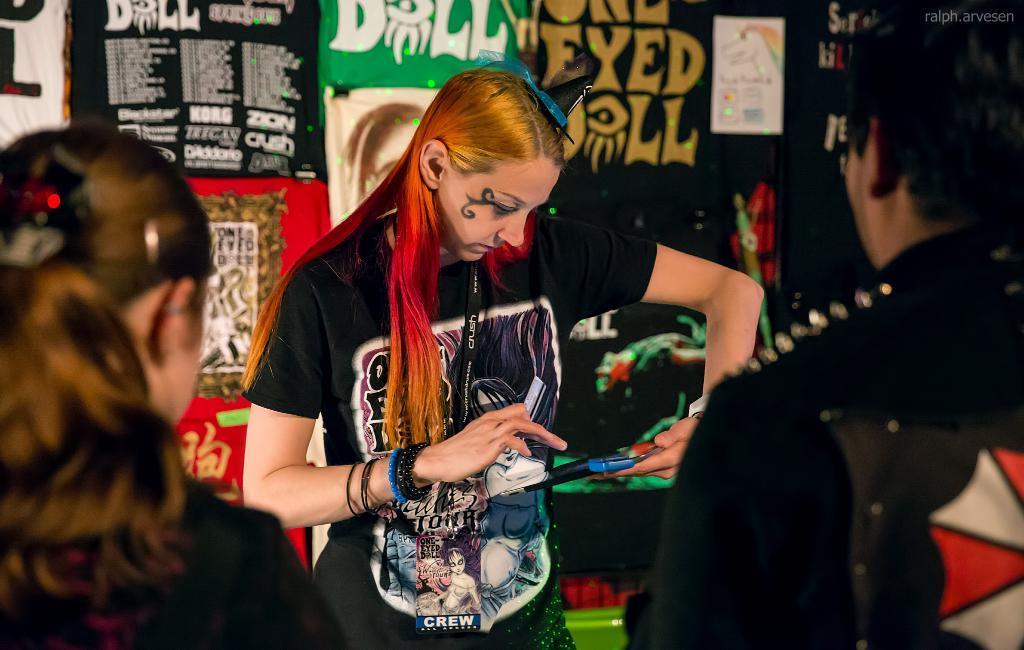Please provide a concise description of this image. In this image I can see three persons standing. In front the person is wearing black color dress and holding some object. In the background I can see few banners in multicolor. 